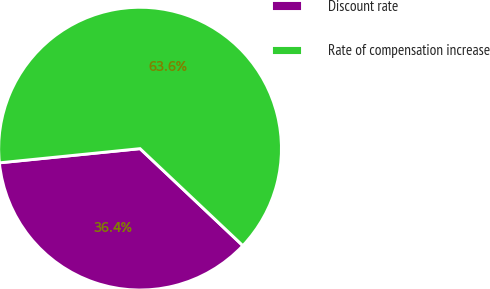Convert chart to OTSL. <chart><loc_0><loc_0><loc_500><loc_500><pie_chart><fcel>Discount rate<fcel>Rate of compensation increase<nl><fcel>36.36%<fcel>63.64%<nl></chart> 